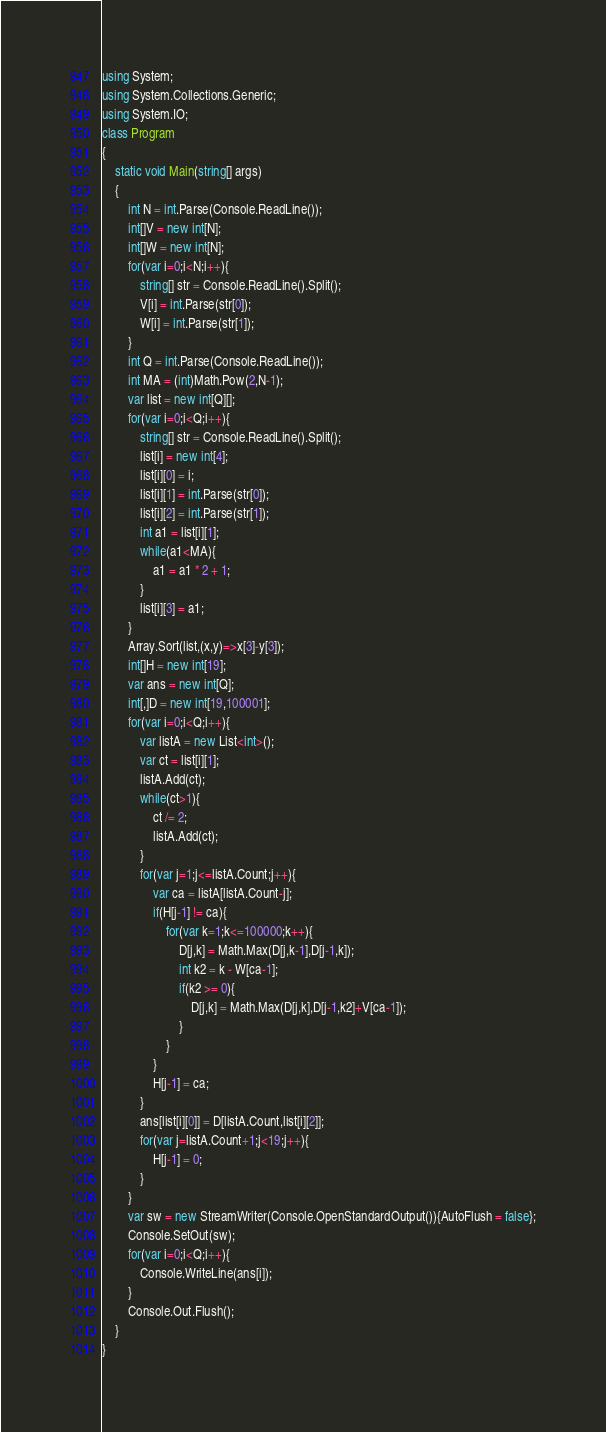Convert code to text. <code><loc_0><loc_0><loc_500><loc_500><_C#_>using System;
using System.Collections.Generic;
using System.IO;
class Program
{
	static void Main(string[] args)
	{
		int N = int.Parse(Console.ReadLine());
		int[]V = new int[N];
		int[]W = new int[N];
		for(var i=0;i<N;i++){
			string[] str = Console.ReadLine().Split();
			V[i] = int.Parse(str[0]);
			W[i] = int.Parse(str[1]);
		}
		int Q = int.Parse(Console.ReadLine());
		int MA = (int)Math.Pow(2,N-1);
		var list = new int[Q][];
		for(var i=0;i<Q;i++){
			string[] str = Console.ReadLine().Split();
			list[i] = new int[4];
			list[i][0] = i;
			list[i][1] = int.Parse(str[0]);
			list[i][2] = int.Parse(str[1]);
			int a1 = list[i][1];
			while(a1<MA){
				a1 = a1 * 2 + 1;
			}
			list[i][3] = a1;
		}
		Array.Sort(list,(x,y)=>x[3]-y[3]);
		int[]H = new int[19];
		var ans = new int[Q];
		int[,]D = new int[19,100001];
		for(var i=0;i<Q;i++){
			var listA = new List<int>();
			var ct = list[i][1];
			listA.Add(ct);
			while(ct>1){
				ct /= 2;
				listA.Add(ct);
			}
			for(var j=1;j<=listA.Count;j++){
				var ca = listA[listA.Count-j];
				if(H[j-1] != ca){
					for(var k=1;k<=100000;k++){
						D[j,k] = Math.Max(D[j,k-1],D[j-1,k]);
						int k2 = k - W[ca-1];
						if(k2 >= 0){
							D[j,k] = Math.Max(D[j,k],D[j-1,k2]+V[ca-1]);
						}
					}
				}
				H[j-1] = ca;
			}
			ans[list[i][0]] = D[listA.Count,list[i][2]];
			for(var j=listA.Count+1;j<19;j++){
				H[j-1] = 0;
			}
		}
		var sw = new StreamWriter(Console.OpenStandardOutput()){AutoFlush = false};
		Console.SetOut(sw);
		for(var i=0;i<Q;i++){
			Console.WriteLine(ans[i]);
		}
		Console.Out.Flush();
	}
}</code> 